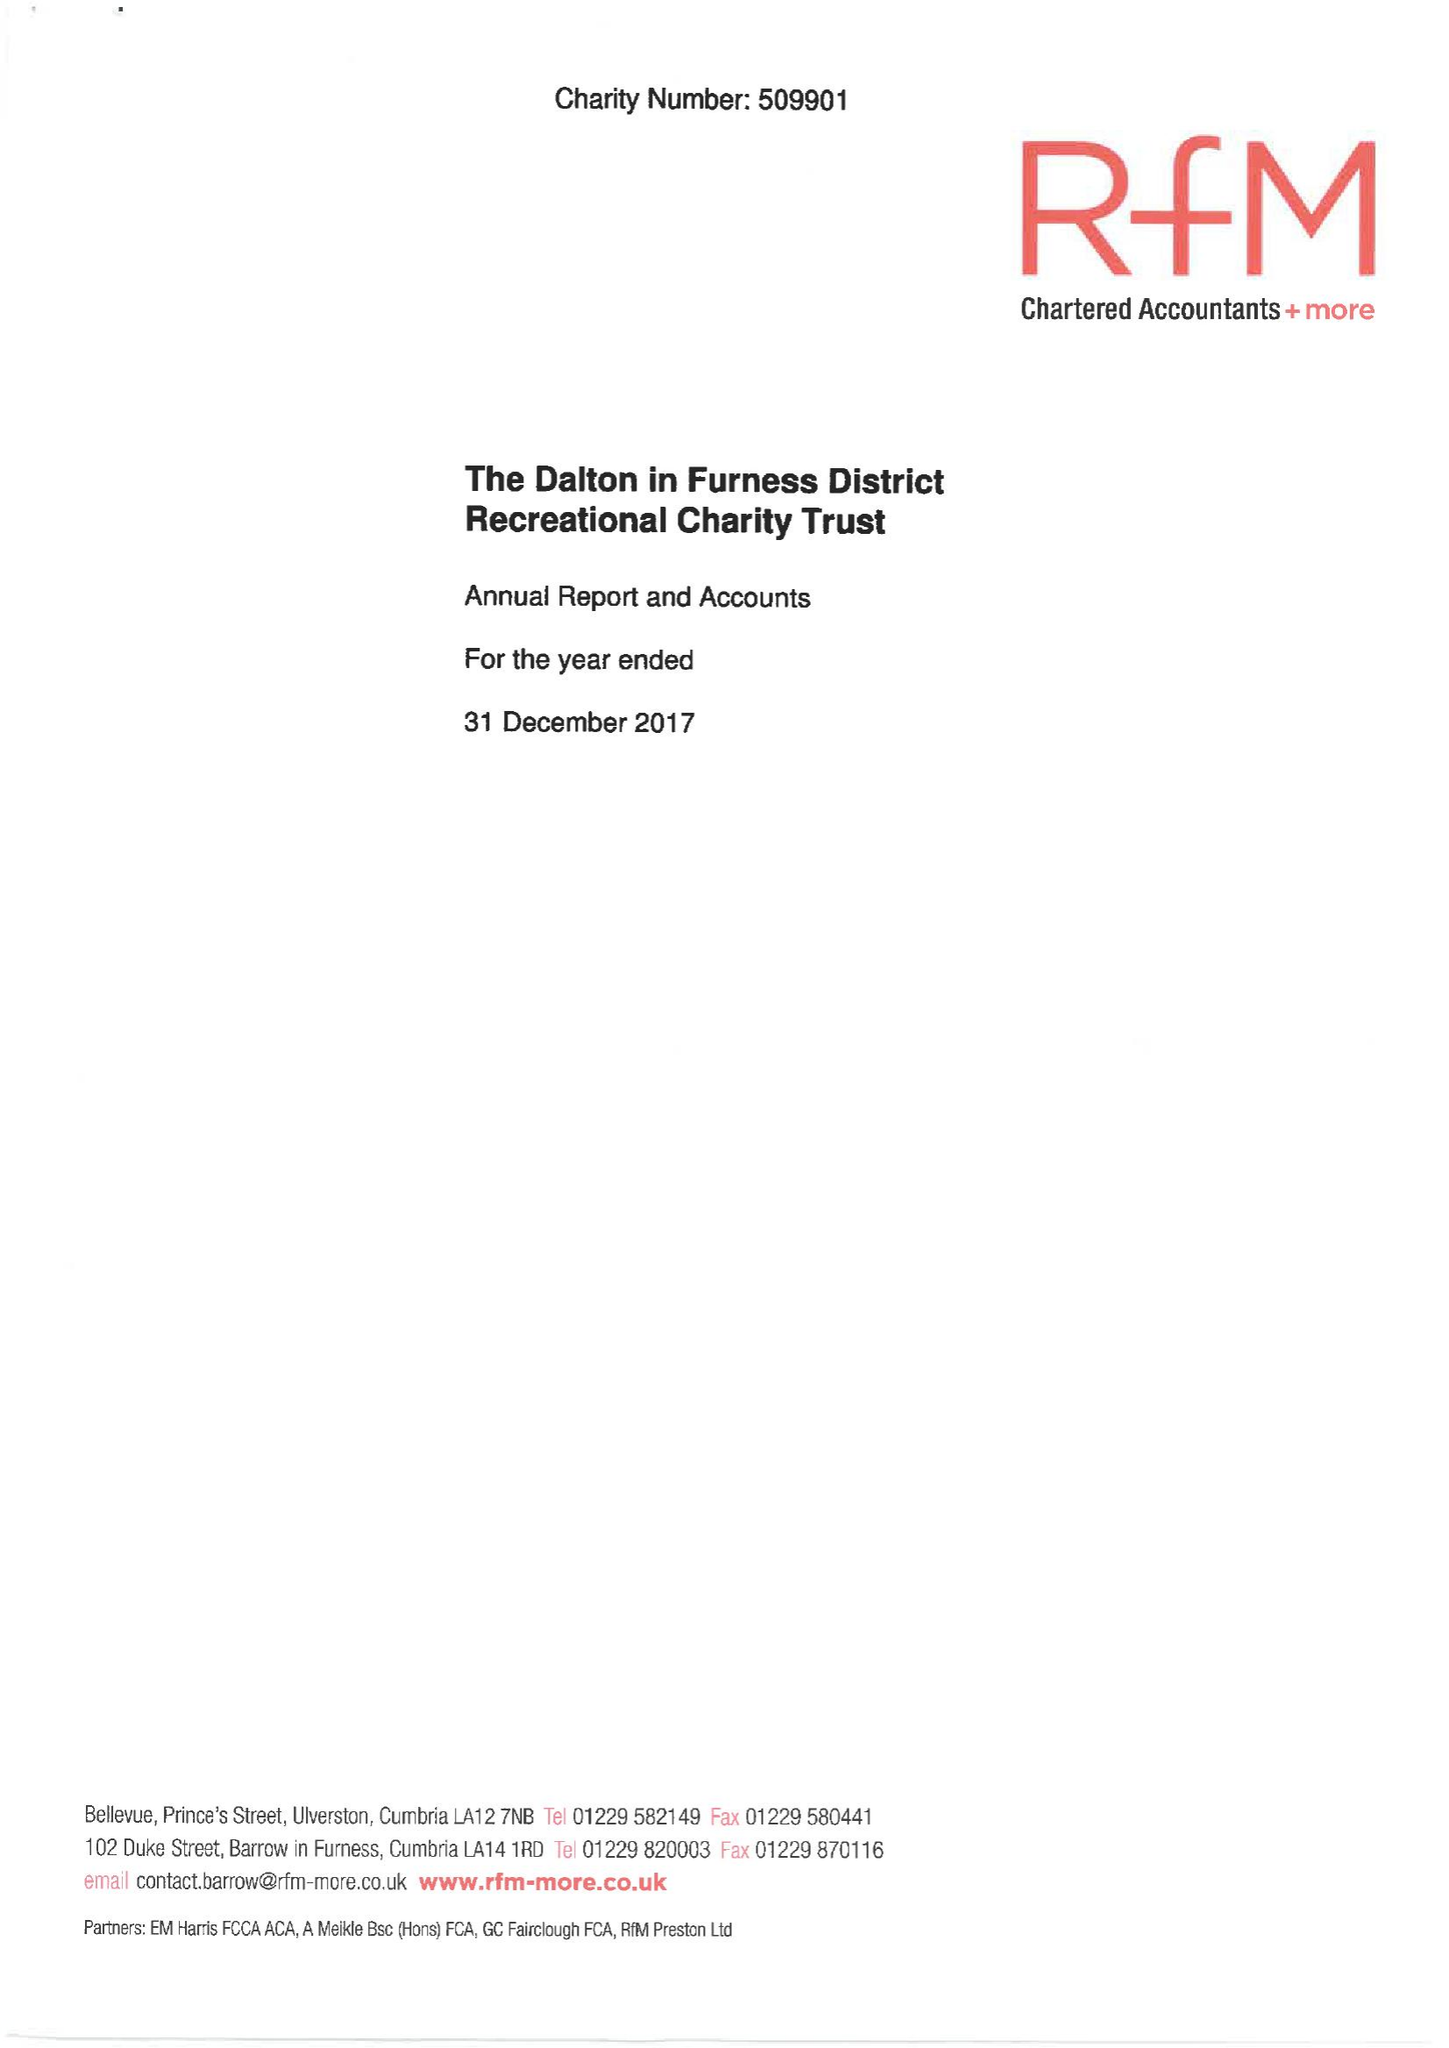What is the value for the spending_annually_in_british_pounds?
Answer the question using a single word or phrase. 28374.00 